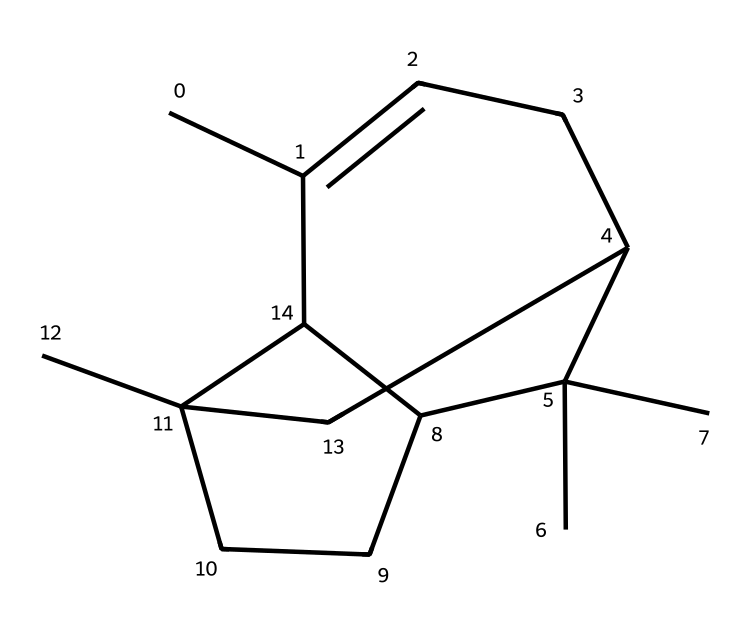What is the molecular formula of beta-caryophyllene? By analyzing the SMILES representation, we can count the number of carbon (C) and hydrogen (H) atoms. In this case, there are 15 carbon atoms and 24 hydrogen atoms, leading to the molecular formula C15H24.
Answer: C15H24 How many rings are present in the structure of beta-caryophyllene? The structure features a total of three rings, which can be identified by visualizing the cyclic components in the SMILES notation.
Answer: 3 What type of bonding is primarily present in beta-caryophyllene? The bonding in beta-caryophyllene primarily consists of single bonds, as indicated by the absence of double or triple bond symbols in the SMILES representation.
Answer: single bond What characteristic feature of terpenes can be found in beta-caryophyllene? Beta-caryophyllene contains a bicyclic structure, which is a common feature in many terpenes, denoting its classification within this compound group.
Answer: bicyclic structure How might the structure of beta-caryophyllene contribute to its analgesic effects? The specific arrangement of atoms and bonds in beta-caryophyllene allows it to interact with CB2 receptors, leading to its potential analgesic effects. This interaction is typical for cannabinoids, which share similar structural attributes.
Answer: interaction with CB2 receptors Is beta-caryophyllene considered a monoterpene or a sesquiterpene? Beta-caryophyllene is classified as a sesquiterpene because it contains 15 carbon atoms, which is characteristic of sesquiterpenes, as monoterpenes contain only 10 carbon atoms.
Answer: sesquiterpene 